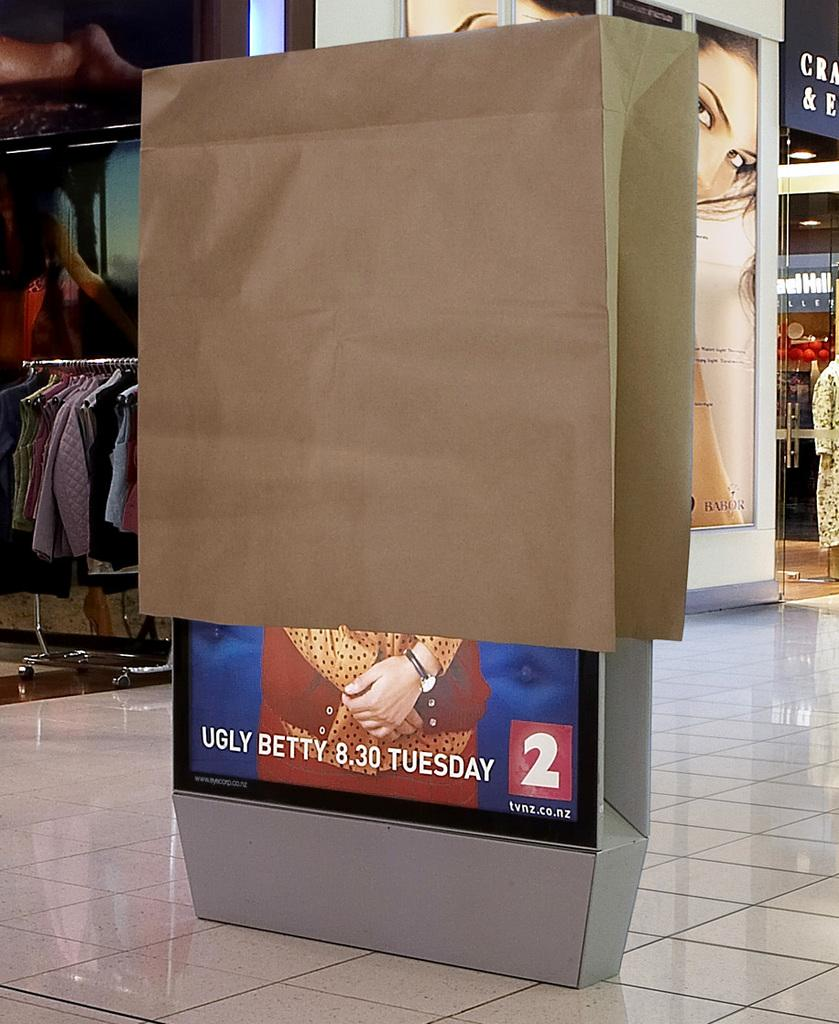What is the main object in the image? There is an LED board in the image. How is the LED board covered? The LED board is covered with a paper bag. What can be seen in the background of the image? There are clothes and boards with photos of women visible in the background. Are there any other objects present in the background? Yes, there are other objects present in the background. What type of pencil is being used to draw on the grandfather's face in the image? There is no pencil or grandfather present in the image. What kind of feast is being prepared in the background of the image? There is no feast preparation visible in the image. 